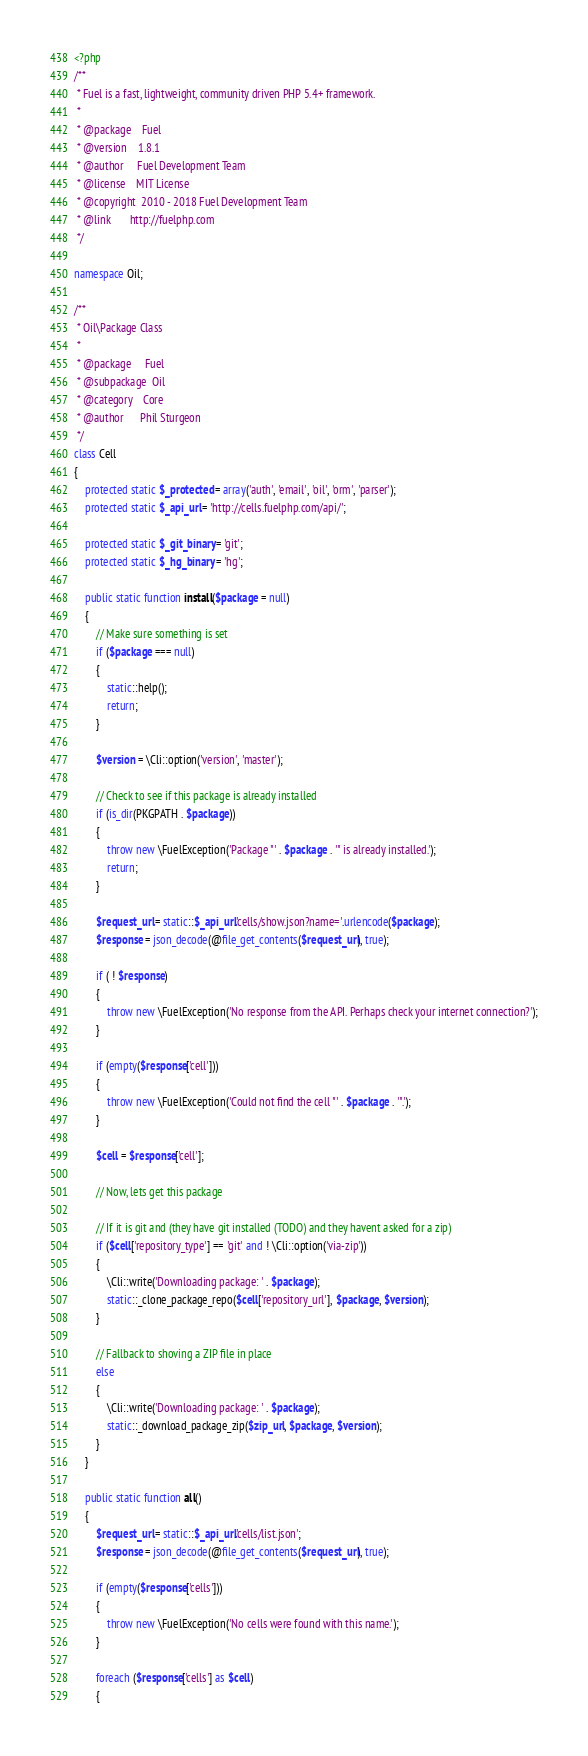<code> <loc_0><loc_0><loc_500><loc_500><_PHP_><?php
/**
 * Fuel is a fast, lightweight, community driven PHP 5.4+ framework.
 *
 * @package    Fuel
 * @version    1.8.1
 * @author     Fuel Development Team
 * @license    MIT License
 * @copyright  2010 - 2018 Fuel Development Team
 * @link       http://fuelphp.com
 */

namespace Oil;

/**
 * Oil\Package Class
 *
 * @package		Fuel
 * @subpackage	Oil
 * @category	Core
 * @author		Phil Sturgeon
 */
class Cell
{
	protected static $_protected = array('auth', 'email', 'oil', 'orm', 'parser');
	protected static $_api_url = 'http://cells.fuelphp.com/api/';

	protected static $_git_binary = 'git';
	protected static $_hg_binary = 'hg';

	public static function install($package = null)
	{
		// Make sure something is set
		if ($package === null)
		{
			static::help();
			return;
		}

		$version = \Cli::option('version', 'master');

		// Check to see if this package is already installed
		if (is_dir(PKGPATH . $package))
		{
			throw new \FuelException('Package "' . $package . '" is already installed.');
			return;
		}

		$request_url = static::$_api_url.'cells/show.json?name='.urlencode($package);
		$response = json_decode(@file_get_contents($request_url), true);

		if ( ! $response)
		{
			throw new \FuelException('No response from the API. Perhaps check your internet connection?');
		}

		if (empty($response['cell']))
		{
			throw new \FuelException('Could not find the cell "' . $package . '".');
		}

		$cell = $response['cell'];

		// Now, lets get this package

		// If it is git and (they have git installed (TODO) and they havent asked for a zip)
		if ($cell['repository_type'] == 'git' and ! \Cli::option('via-zip'))
		{
			\Cli::write('Downloading package: ' . $package);
			static::_clone_package_repo($cell['repository_url'], $package, $version);
		}

		// Fallback to shoving a ZIP file in place
		else
		{
			\Cli::write('Downloading package: ' . $package);
			static::_download_package_zip($zip_url, $package, $version);
		}
	}

	public static function all()
	{
		$request_url = static::$_api_url.'cells/list.json';
		$response = json_decode(@file_get_contents($request_url), true);

		if (empty($response['cells']))
		{
			throw new \FuelException('No cells were found with this name.');
		}

		foreach ($response['cells'] as $cell)
		{</code> 